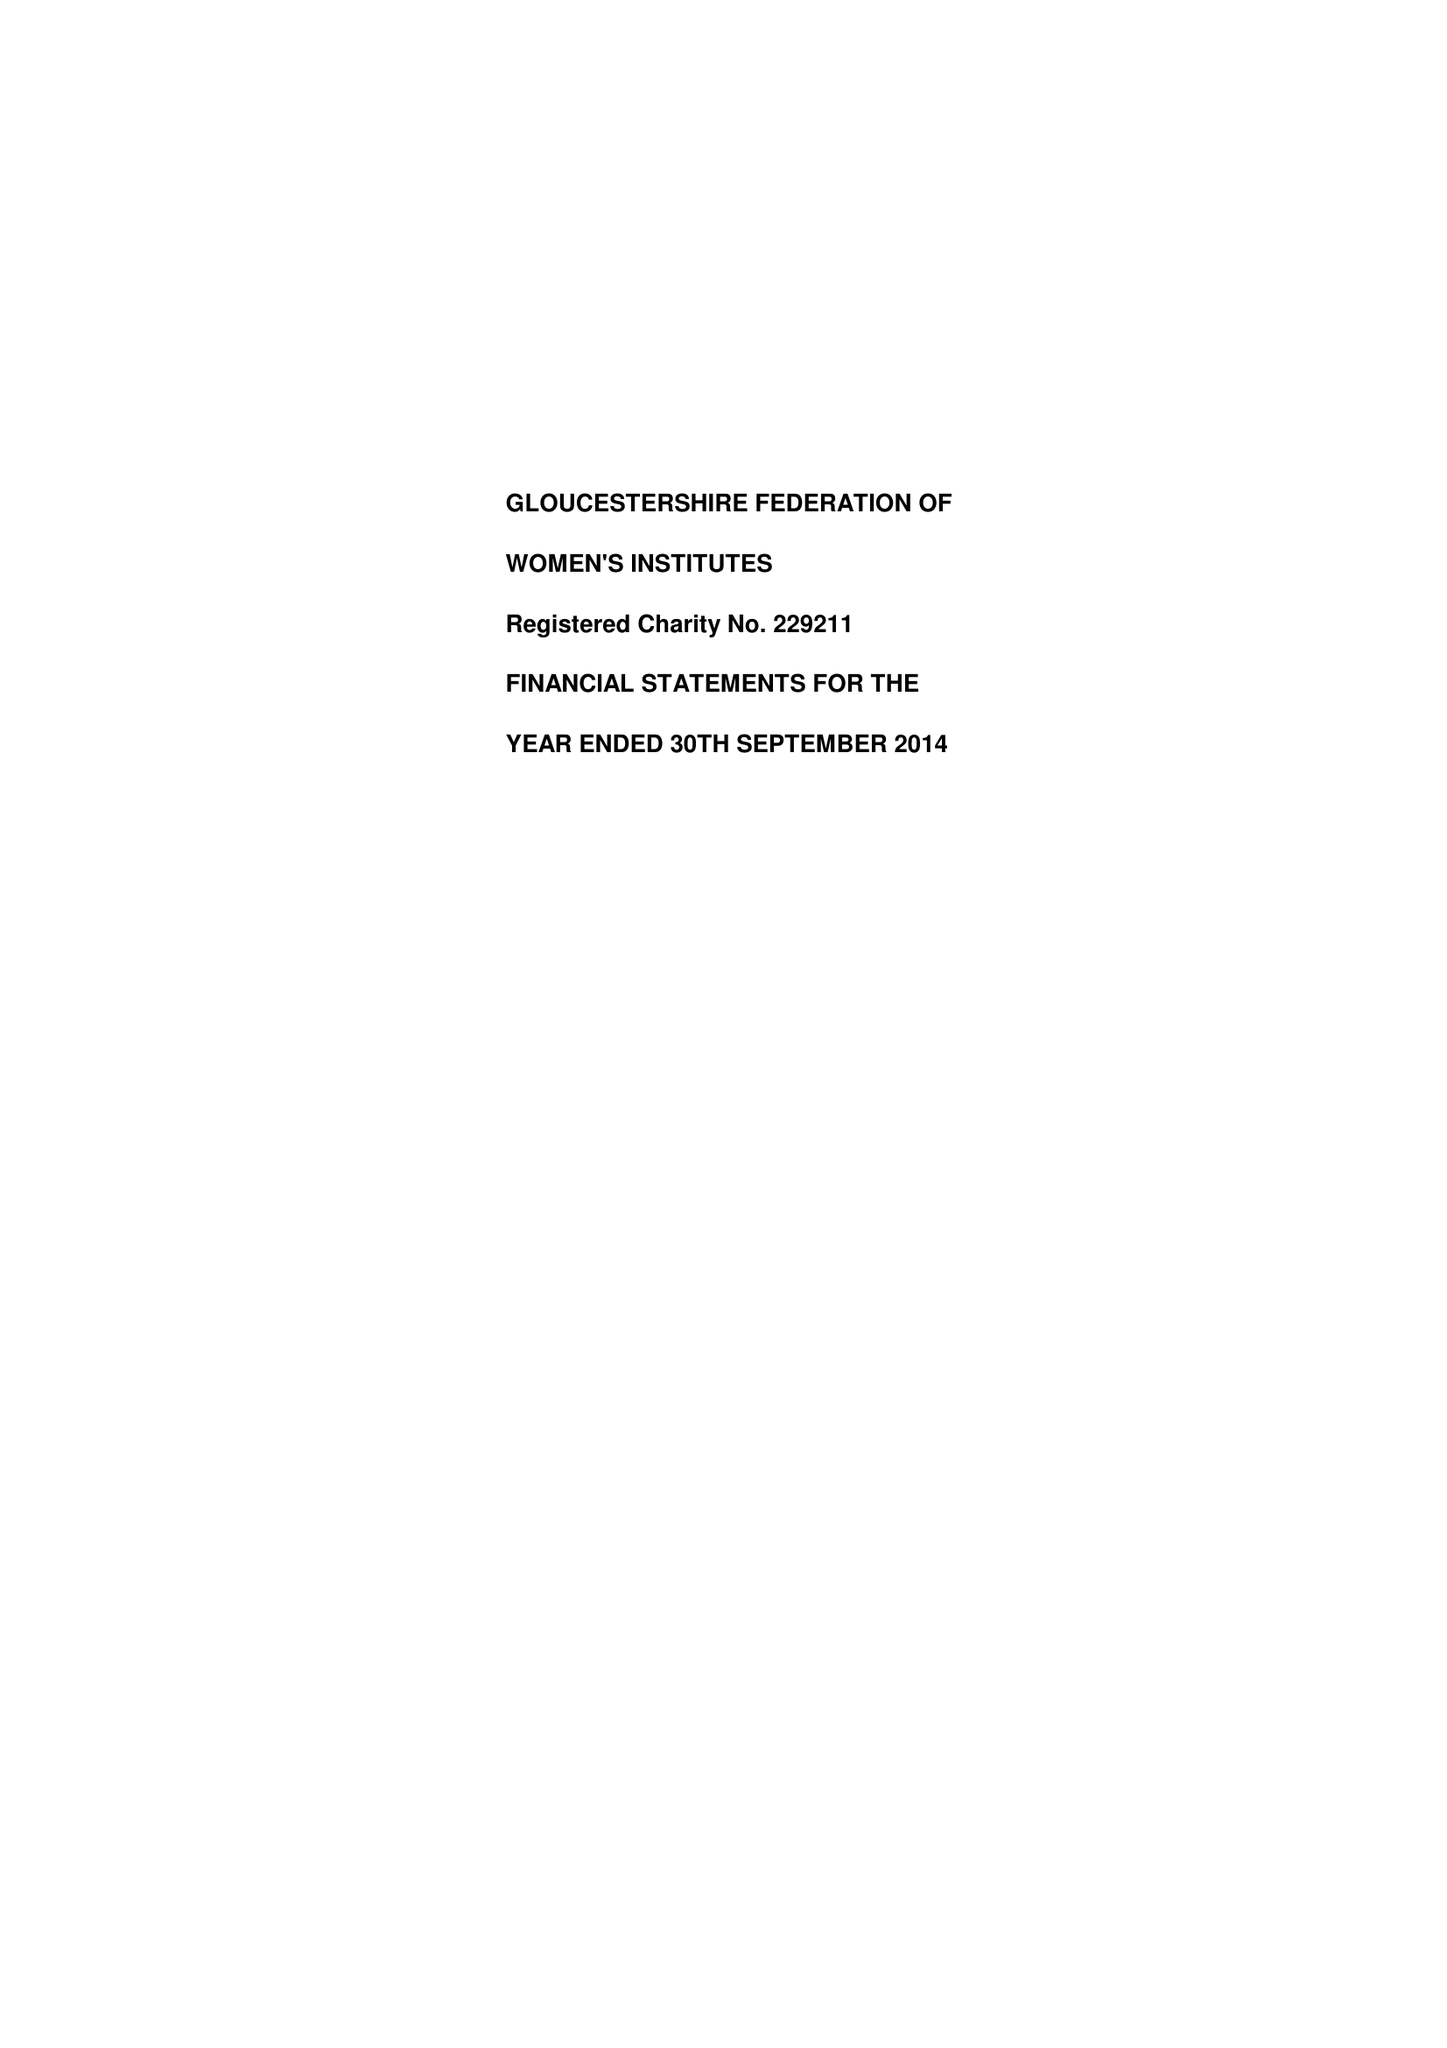What is the value for the charity_number?
Answer the question using a single word or phrase. 229211 